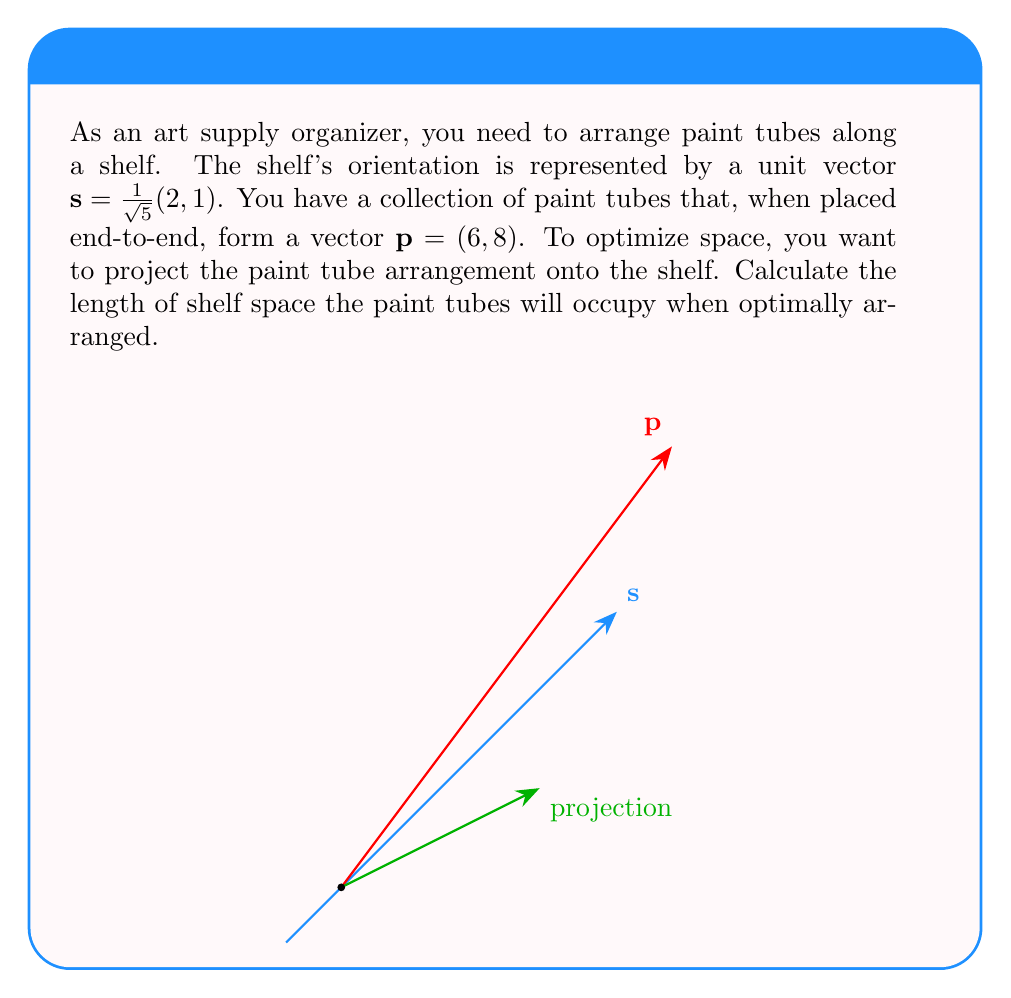Solve this math problem. To find the optimal arrangement, we need to project vector $\mathbf{p}$ onto vector $\mathbf{s}$. The formula for vector projection is:

$$\text{proj}_\mathbf{s}\mathbf{p} = \frac{\mathbf{p} \cdot \mathbf{s}}{\|\mathbf{s}\|^2} \mathbf{s}$$

Step 1: Calculate the dot product $\mathbf{p} \cdot \mathbf{s}$
$$\mathbf{p} \cdot \mathbf{s} = (6, 8) \cdot \frac{1}{\sqrt{5}}(2, 1) = \frac{1}{\sqrt{5}}(12 + 8) = \frac{20}{\sqrt{5}}$$

Step 2: Calculate $\|\mathbf{s}\|^2$
Since $\mathbf{s}$ is a unit vector, $\|\mathbf{s}\|^2 = 1$

Step 3: Calculate the projection
$$\text{proj}_\mathbf{s}\mathbf{p} = \frac{20}{\sqrt{5}} \cdot \frac{1}{\sqrt{5}}(2, 1) = \frac{4}{\sqrt{5}}(2, 1) = (4\sqrt{5}, 2\sqrt{5})$$

Step 4: Calculate the length of the projection
$$\|\text{proj}_\mathbf{s}\mathbf{p}\| = \sqrt{(4\sqrt{5})^2 + (2\sqrt{5})^2} = \sqrt{80 + 20} = \sqrt{100} = 10$$

Therefore, the paint tubes will occupy 10 units of shelf space when optimally arranged.
Answer: $10$ units 